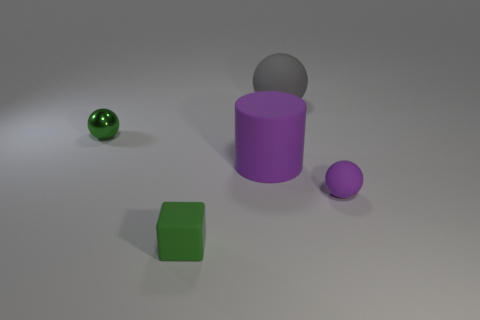Is there a gray object of the same size as the green metal ball?
Provide a short and direct response. No. Do the large matte cylinder and the tiny matte cube have the same color?
Provide a succinct answer. No. There is a big object that is behind the small green metal ball that is in front of the gray thing; what color is it?
Your answer should be compact. Gray. What number of small objects are both behind the small rubber cube and left of the gray matte thing?
Your response must be concise. 1. What number of other small objects are the same shape as the tiny green shiny object?
Offer a terse response. 1. Is the material of the big ball the same as the tiny green cube?
Offer a very short reply. Yes. The green rubber thing to the left of the purple object behind the small purple ball is what shape?
Make the answer very short. Cube. What number of purple things are on the left side of the small ball that is right of the gray rubber object?
Your response must be concise. 1. What is the material of the tiny object that is both behind the small green matte block and in front of the metal thing?
Offer a very short reply. Rubber. There is a purple thing that is the same size as the gray matte ball; what is its shape?
Your response must be concise. Cylinder. 